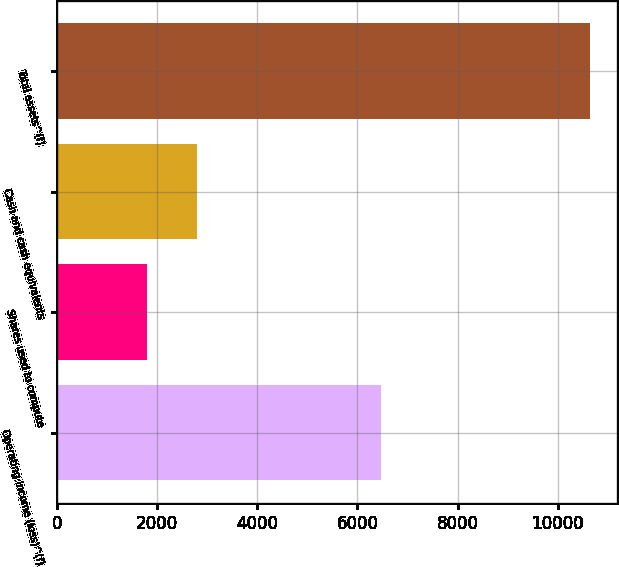Convert chart. <chart><loc_0><loc_0><loc_500><loc_500><bar_chart><fcel>Operating income (loss)^(f)<fcel>Shares used to compute<fcel>Cash and cash equivalents<fcel>Total assets^(f)<nl><fcel>6470<fcel>1811.7<fcel>2792.4<fcel>10638<nl></chart> 